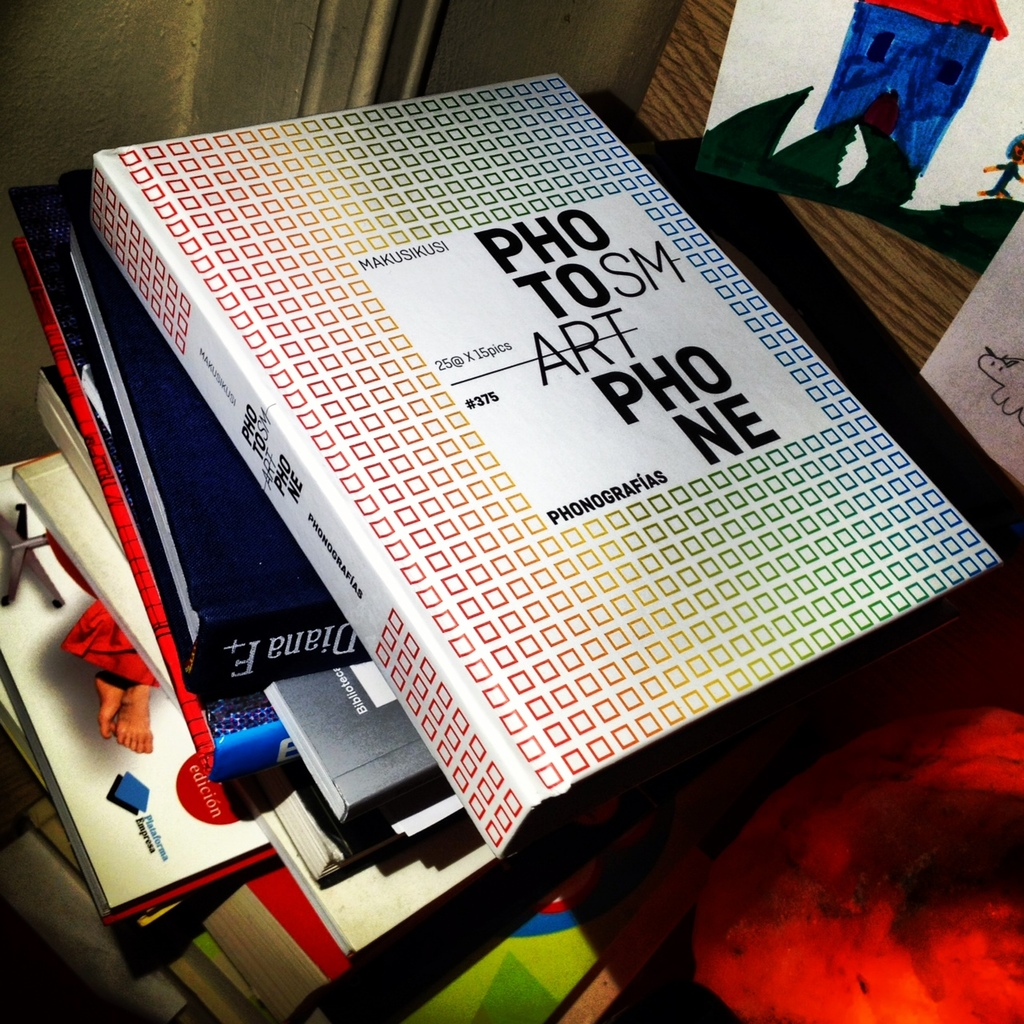Provide a one-sentence caption for the provided image. The image captures a colorful book with a vibrant mosaic of small squares titled 'PHOTOSMART' lying atop a stack of assorted books and art supplies, hinting at a creative or academic environment. 